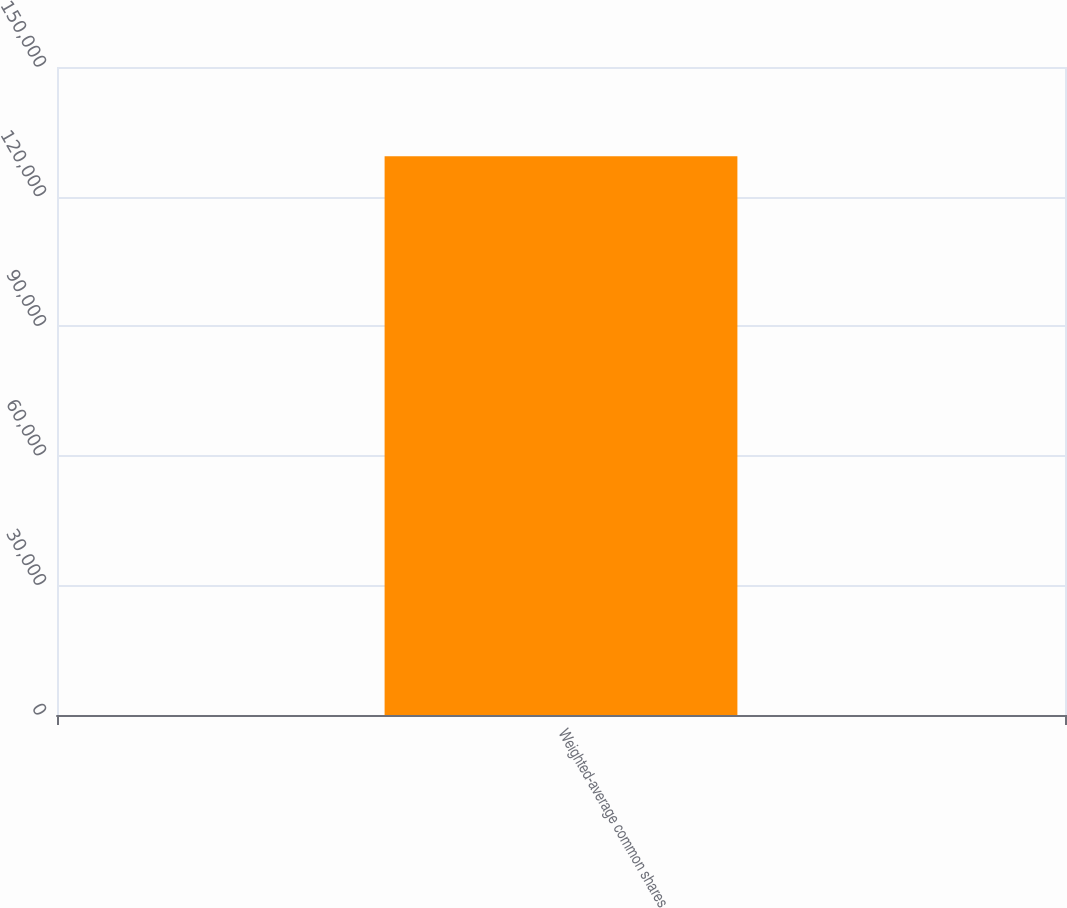<chart> <loc_0><loc_0><loc_500><loc_500><bar_chart><fcel>Weighted-average common shares<nl><fcel>129318<nl></chart> 